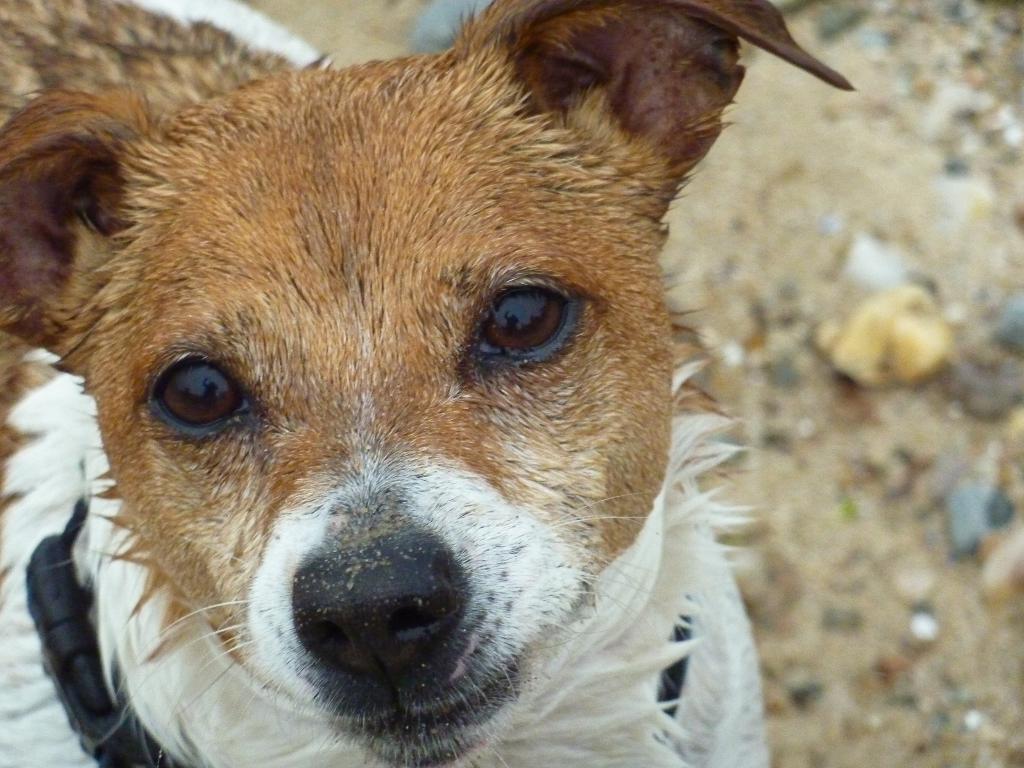Can you describe this image briefly? In this image, we can see a dog is watching. Background we can see blur view. On the right side of the image, there is a ground. 